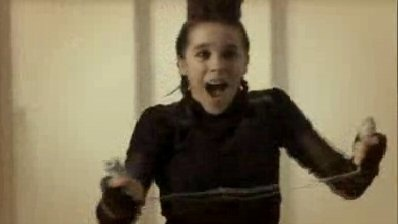Describe the objects in this image and their specific colors. I can see people in gray, black, and maroon tones, remote in gray, tan, and olive tones, and remote in gray tones in this image. 